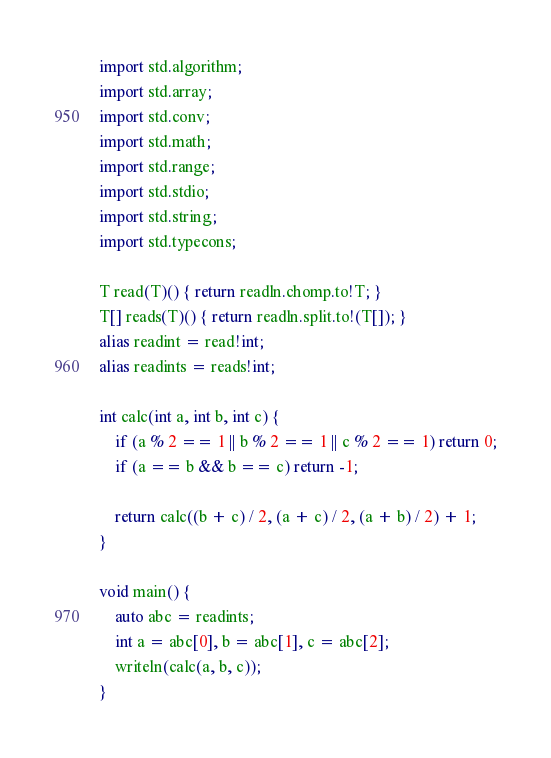<code> <loc_0><loc_0><loc_500><loc_500><_D_>import std.algorithm;
import std.array;
import std.conv;
import std.math;
import std.range;
import std.stdio;
import std.string;
import std.typecons;

T read(T)() { return readln.chomp.to!T; }
T[] reads(T)() { return readln.split.to!(T[]); }
alias readint = read!int;
alias readints = reads!int;

int calc(int a, int b, int c) {
    if (a % 2 == 1 || b % 2 == 1 || c % 2 == 1) return 0;
    if (a == b && b == c) return -1;

    return calc((b + c) / 2, (a + c) / 2, (a + b) / 2) + 1;
}

void main() {
    auto abc = readints;
    int a = abc[0], b = abc[1], c = abc[2];
    writeln(calc(a, b, c));
}
</code> 